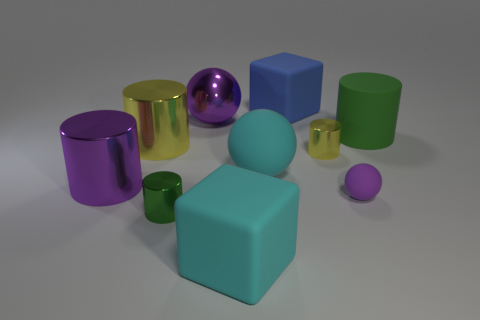Which object in the image is the largest? The largest object in the image is the light blue cube in the center. Its volume appears greater than that of the other shapes surrounding it. 